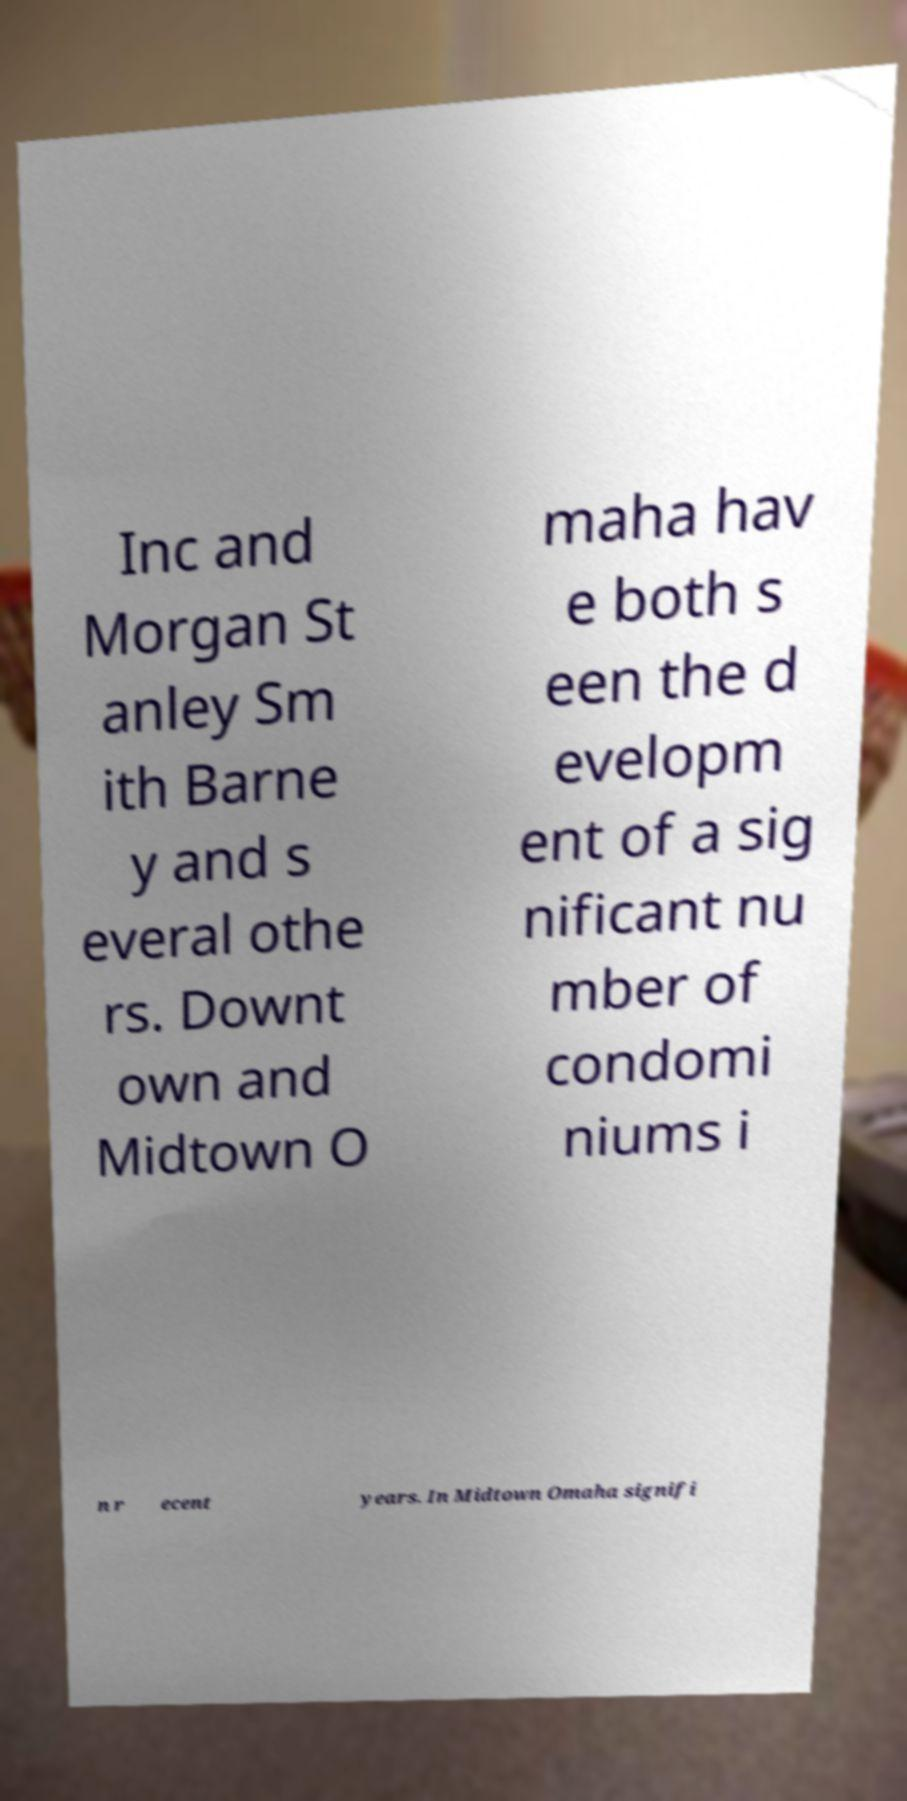Could you assist in decoding the text presented in this image and type it out clearly? Inc and Morgan St anley Sm ith Barne y and s everal othe rs. Downt own and Midtown O maha hav e both s een the d evelopm ent of a sig nificant nu mber of condomi niums i n r ecent years. In Midtown Omaha signifi 